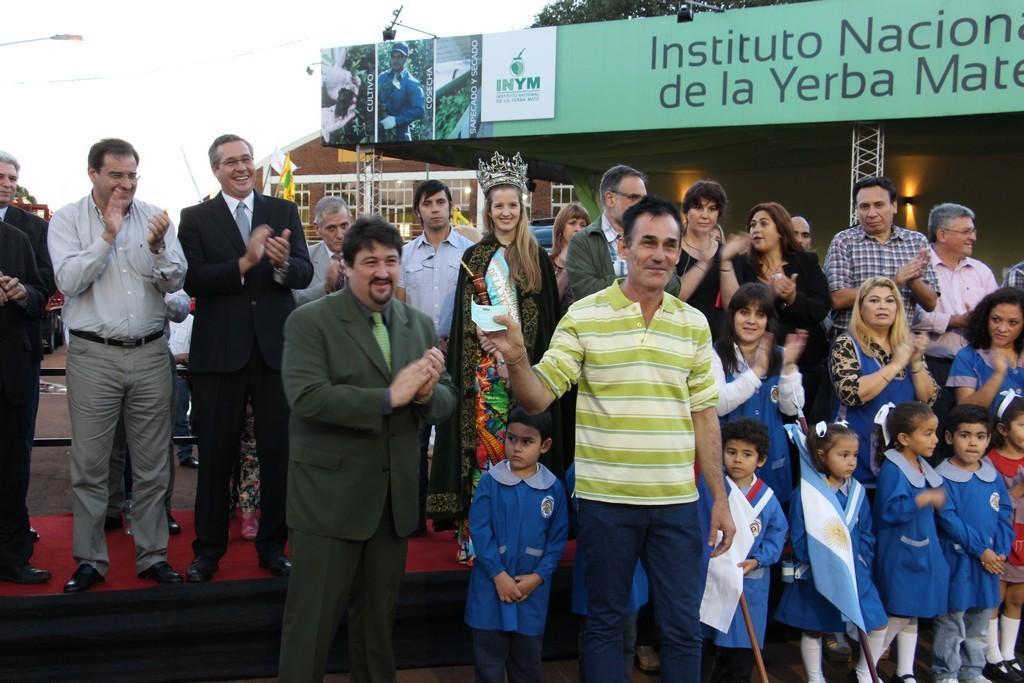Describe this image in one or two sentences. In this image there are a few people standing and few are clapping their hands, behind them there are buildings, trees and the sky. 